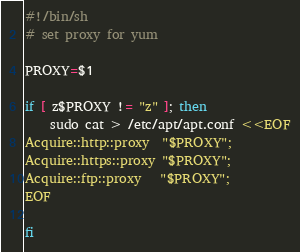<code> <loc_0><loc_0><loc_500><loc_500><_Bash_>#!/bin/sh
# set proxy for yum

PROXY=$1

if [ z$PROXY != "z" ]; then
    sudo cat > /etc/apt/apt.conf <<EOF
Acquire::http::proxy  "$PROXY";
Acquire::https::proxy "$PROXY";
Acquire::ftp::proxy   "$PROXY"; 
EOF

fi
</code> 